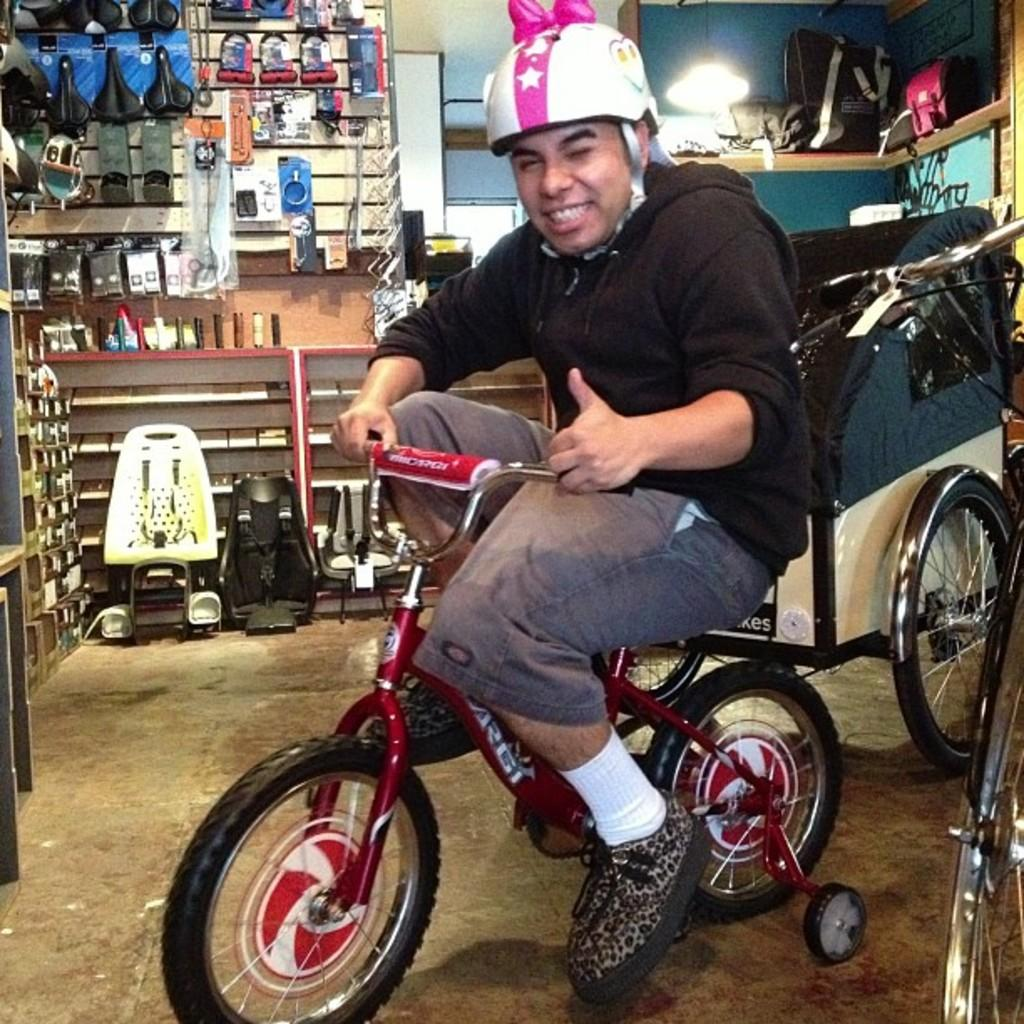Who or what is the main subject in the image? There is a person in the image. What is the person wearing? The person is wearing a helmet. What is the person doing in the image? The person is sitting on a bicycle. What can be inferred about the setting from the objects placed behind the person? The objects placed behind the person suggest a shop-like setting. Can you see any ducks writing on the wall in the image? There are no ducks or writing on the wall in the image. 